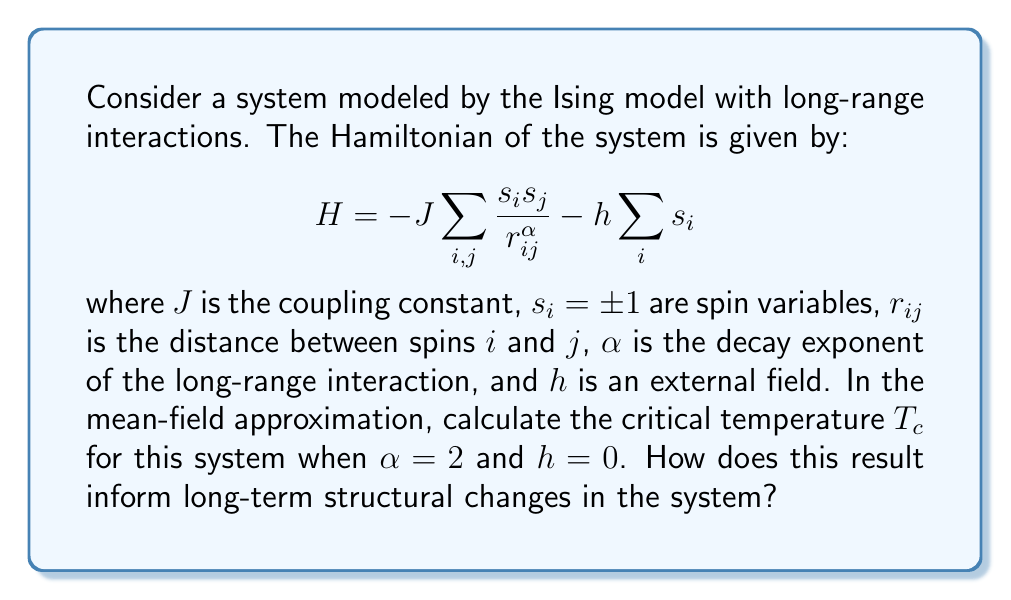Solve this math problem. To solve this problem, we'll follow these steps:

1) In the mean-field approximation, we replace the spin-spin interaction term with an average field:

   $$s_i s_j \approx s_i \langle s \rangle + s_j \langle s \rangle - \langle s \rangle^2$$

2) The mean-field Hamiltonian becomes:

   $$H_{MF} = -J \sum_{i,j} \frac{\langle s \rangle (s_i + s_j - \langle s \rangle)}{r_{ij}^\alpha} - h \sum_i s_i$$

3) The magnetization $m = \langle s \rangle$ satisfies the self-consistency equation:

   $$m = \tanh(\beta J z m + \beta h)$$

   where $\beta = 1/(k_B T)$ and $z$ is the effective number of neighbors.

4) For long-range interactions with $\alpha = 2$, the effective number of neighbors $z$ is proportional to the system size $N$:

   $$z \propto \int_0^L r dr \frac{1}{r^2} \propto L \propto N^{1/d}$$

   where $d$ is the dimensionality of the system.

5) At the critical temperature and zero external field $(h = 0)$, the self-consistency equation becomes:

   $$m = \tanh(\beta_c J z m)$$

6) For small $m$, we can expand $\tanh(x) \approx x - \frac{1}{3}x^3$:

   $$m \approx \beta_c J z m - \frac{1}{3}(\beta_c J z)^3 m^3$$

7) The critical temperature is found when the coefficient of $m$ equals 1:

   $$\beta_c J z = 1$$

8) Therefore, the critical temperature is:

   $$T_c = \frac{J z}{k_B}$$

9) Since $z \propto N^{1/d}$, we have:

   $$T_c \propto N^{1/d}$$

This result informs long-term structural changes by showing that the critical temperature scales with system size. As the system grows, the phase transition occurs at higher temperatures, indicating increased stability of the ordered phase. This suggests that larger systems are more resistant to thermal fluctuations and maintain their structure over longer time scales.
Answer: $T_c \propto N^{1/d}$ 